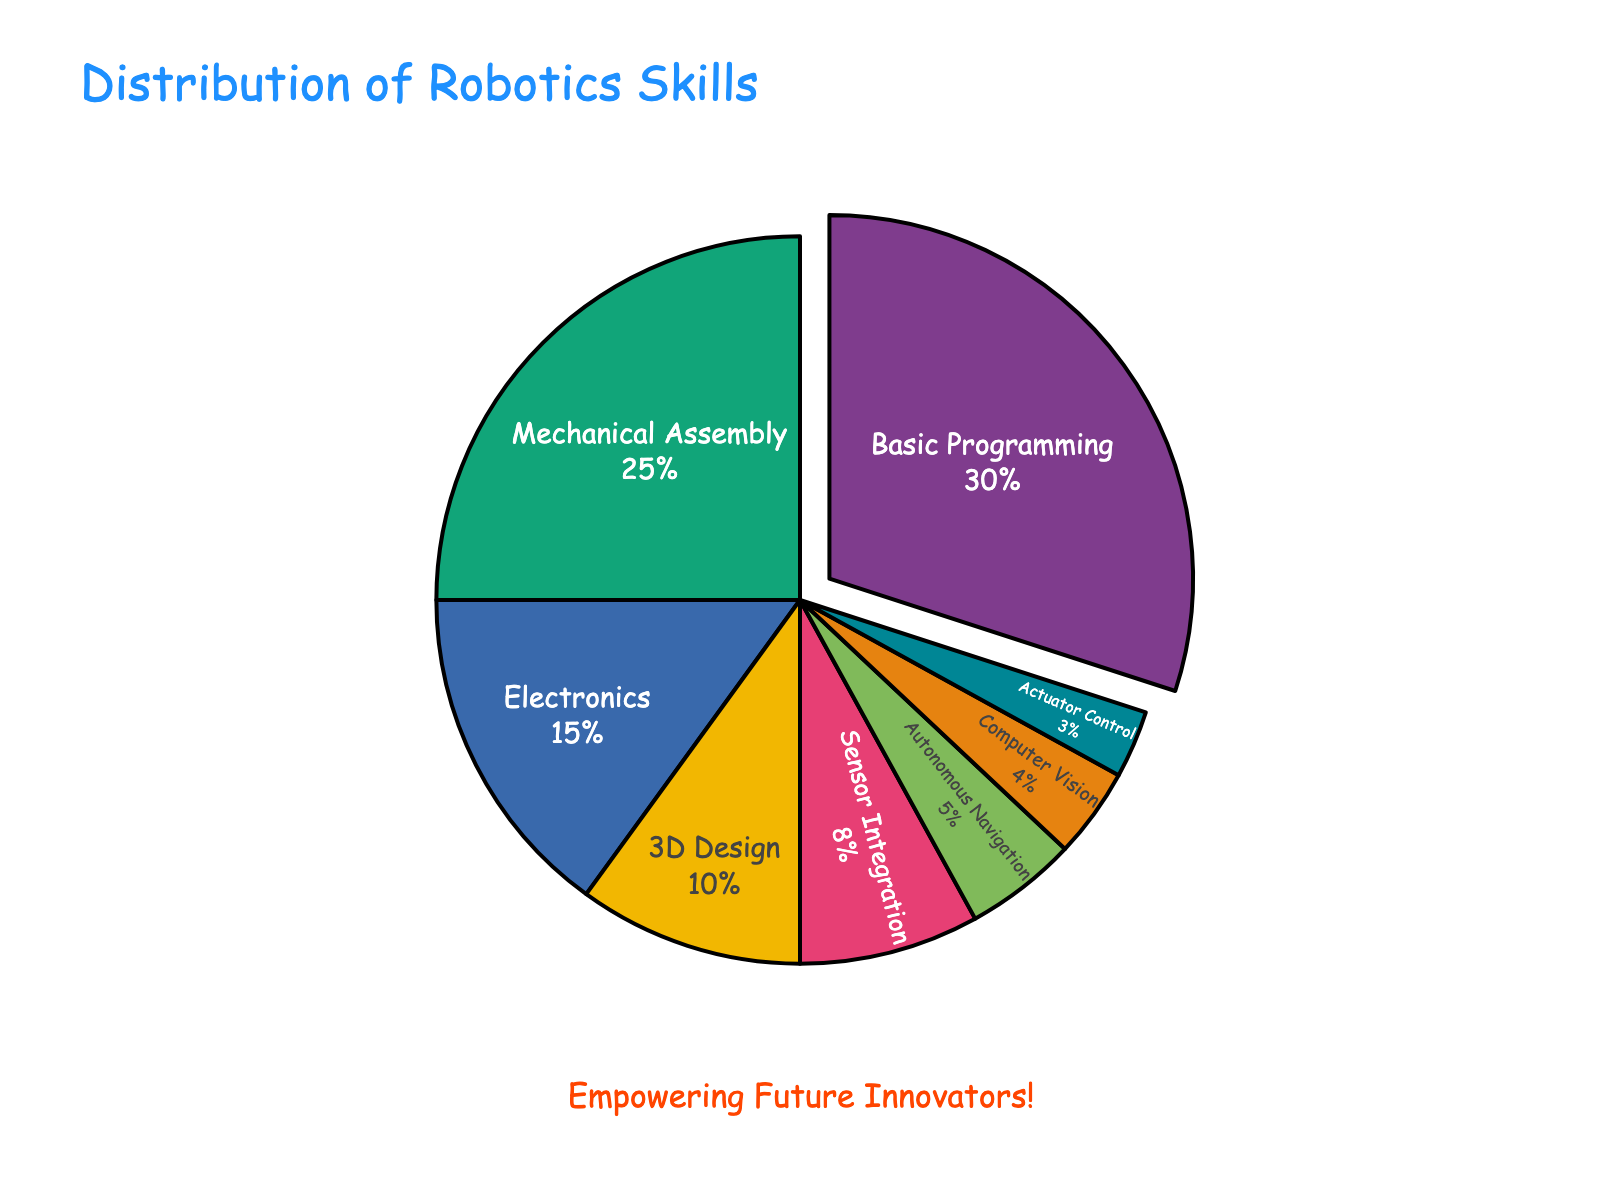What is the most common robotics skill among students? Look at the largest segment in the pie chart, which represents the highest percentage. It is labeled with "Basic Programming" and has the largest area.
Answer: Basic Programming Which skill is more common, Mechanical Assembly or Electronics? Compare the sizes of the segments labeled "Mechanical Assembly" and "Electronics". The percentage for Mechanical Assembly is 25%, while Electronics is 15%.
Answer: Mechanical Assembly What is the total percentage of students skilled in Sensor Integration and Autonomous Navigation combined? Add the percentages for Sensor Integration (8%) and Autonomous Navigation (5%): 8 + 5 = 13
Answer: 13% Which skill has the smallest representation? Identify the smallest segment in the pie chart, which corresponds to the smallest percentage. The segment labeled "Actuator Control" is the smallest at 3%.
Answer: Actuator Control How much larger is the Basic Programming segment compared to the 3D Design segment? Calculate the difference between the percentages for Basic Programming (30%) and 3D Design (10%): 30 - 10 = 20
Answer: 20% Are there more students skilled in Electronics or Computer Vision? Compare the sizes of the segments labeled "Electronics" and "Computer Vision". Electronics has 15%, while Computer Vision has 4%.
Answer: Electronics What fraction of the students are skilled in either Basic Programming or Mechanical Assembly? Calculate the sum of the percentages for Basic Programming (30%) and Mechanical Assembly (25%): 30 + 25 = 55
Answer: 55% Which three skills have the lowest percentages? Identify the three smallest segments in the pie chart: Actuator Control (3%), Computer Vision (4%), Autonomous Navigation (5%).
Answer: Actuator Control, Computer Vision, Autonomous Navigation By what percentage does Mechanical Assembly exceed 3D Design? Calculate the difference between the percentages for Mechanical Assembly (25%) and 3D Design (10%): 25 - 10 = 15
Answer: 15% What is the combined percentage of students skilled in 3D Design and Computer Vision? Add the percentages for 3D Design (10%) and Computer Vision (4%): 10 + 4 = 14
Answer: 14% 